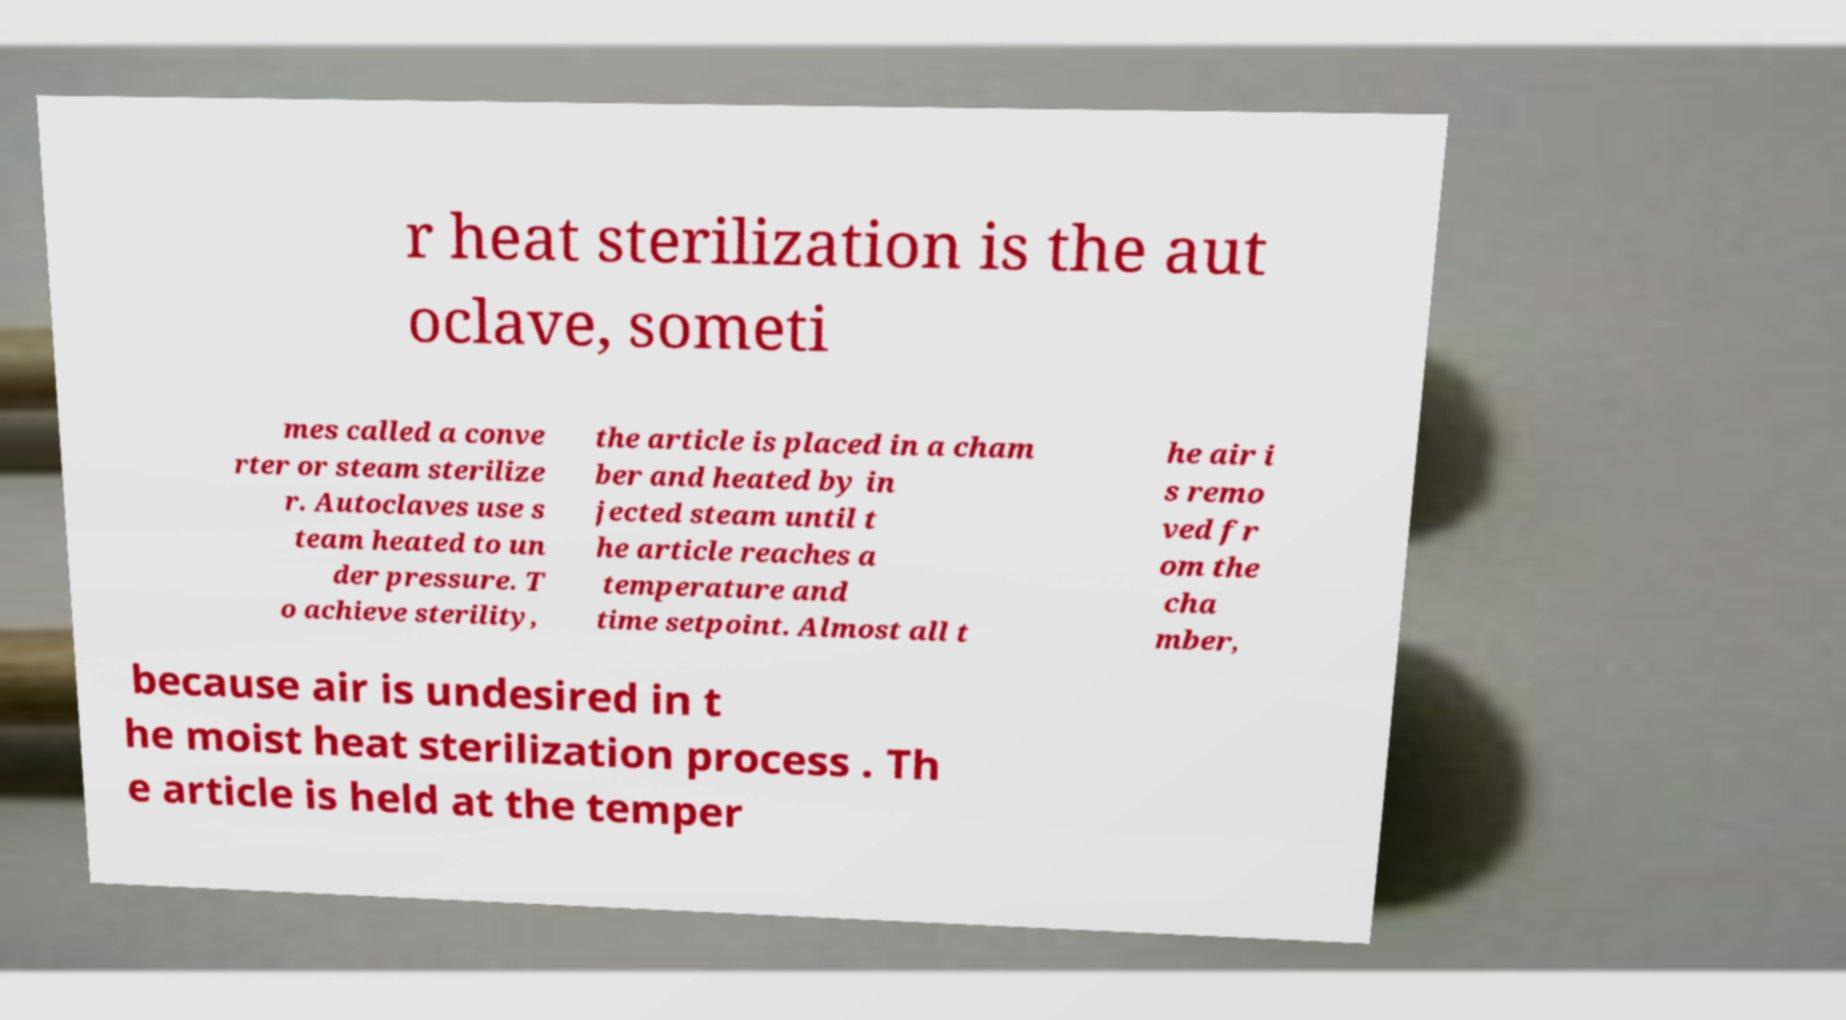I need the written content from this picture converted into text. Can you do that? r heat sterilization is the aut oclave, someti mes called a conve rter or steam sterilize r. Autoclaves use s team heated to un der pressure. T o achieve sterility, the article is placed in a cham ber and heated by in jected steam until t he article reaches a temperature and time setpoint. Almost all t he air i s remo ved fr om the cha mber, because air is undesired in t he moist heat sterilization process . Th e article is held at the temper 